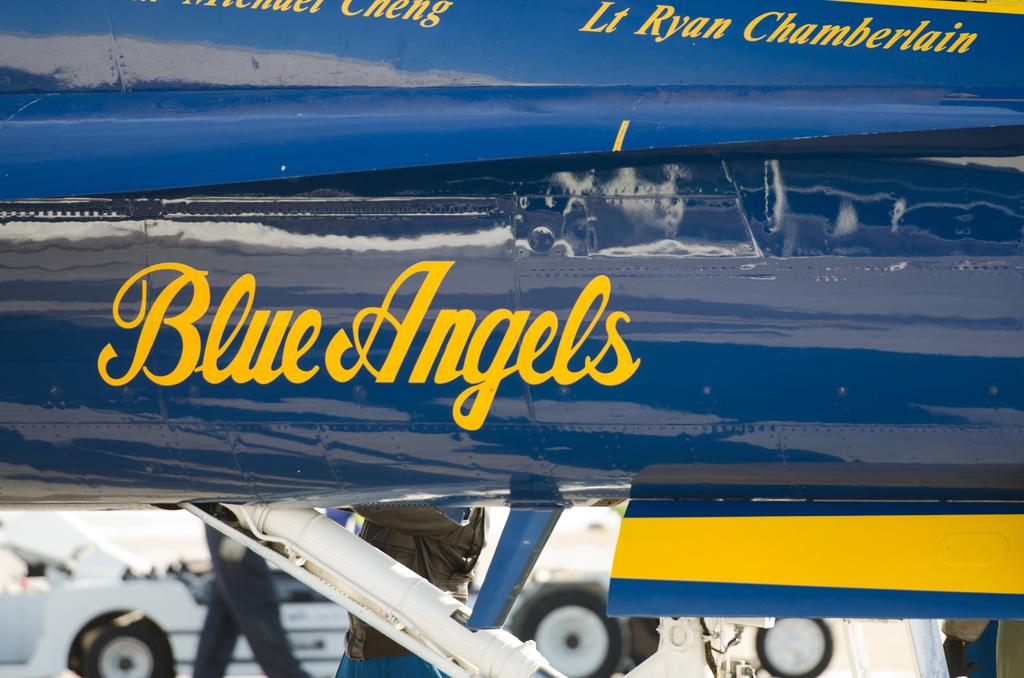What is written in yellow on these planes?
Your response must be concise. Blue angels. What is the lieutenant's name?
Give a very brief answer. Ryan chamberlain. 